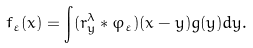Convert formula to latex. <formula><loc_0><loc_0><loc_500><loc_500>f _ { \varepsilon } ( x ) = \int ( r _ { y } ^ { \lambda } * \varphi _ { \varepsilon } ) ( x - y ) g ( y ) d y .</formula> 